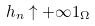<formula> <loc_0><loc_0><loc_500><loc_500>h _ { n } \uparrow + \infty 1 _ { \Omega }</formula> 